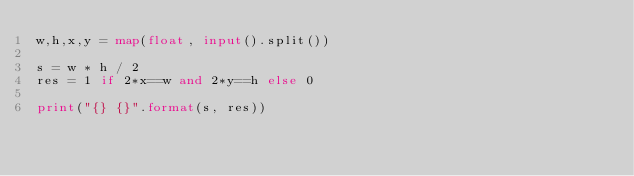<code> <loc_0><loc_0><loc_500><loc_500><_Python_>w,h,x,y = map(float, input().split())

s = w * h / 2
res = 1 if 2*x==w and 2*y==h else 0

print("{} {}".format(s, res))</code> 